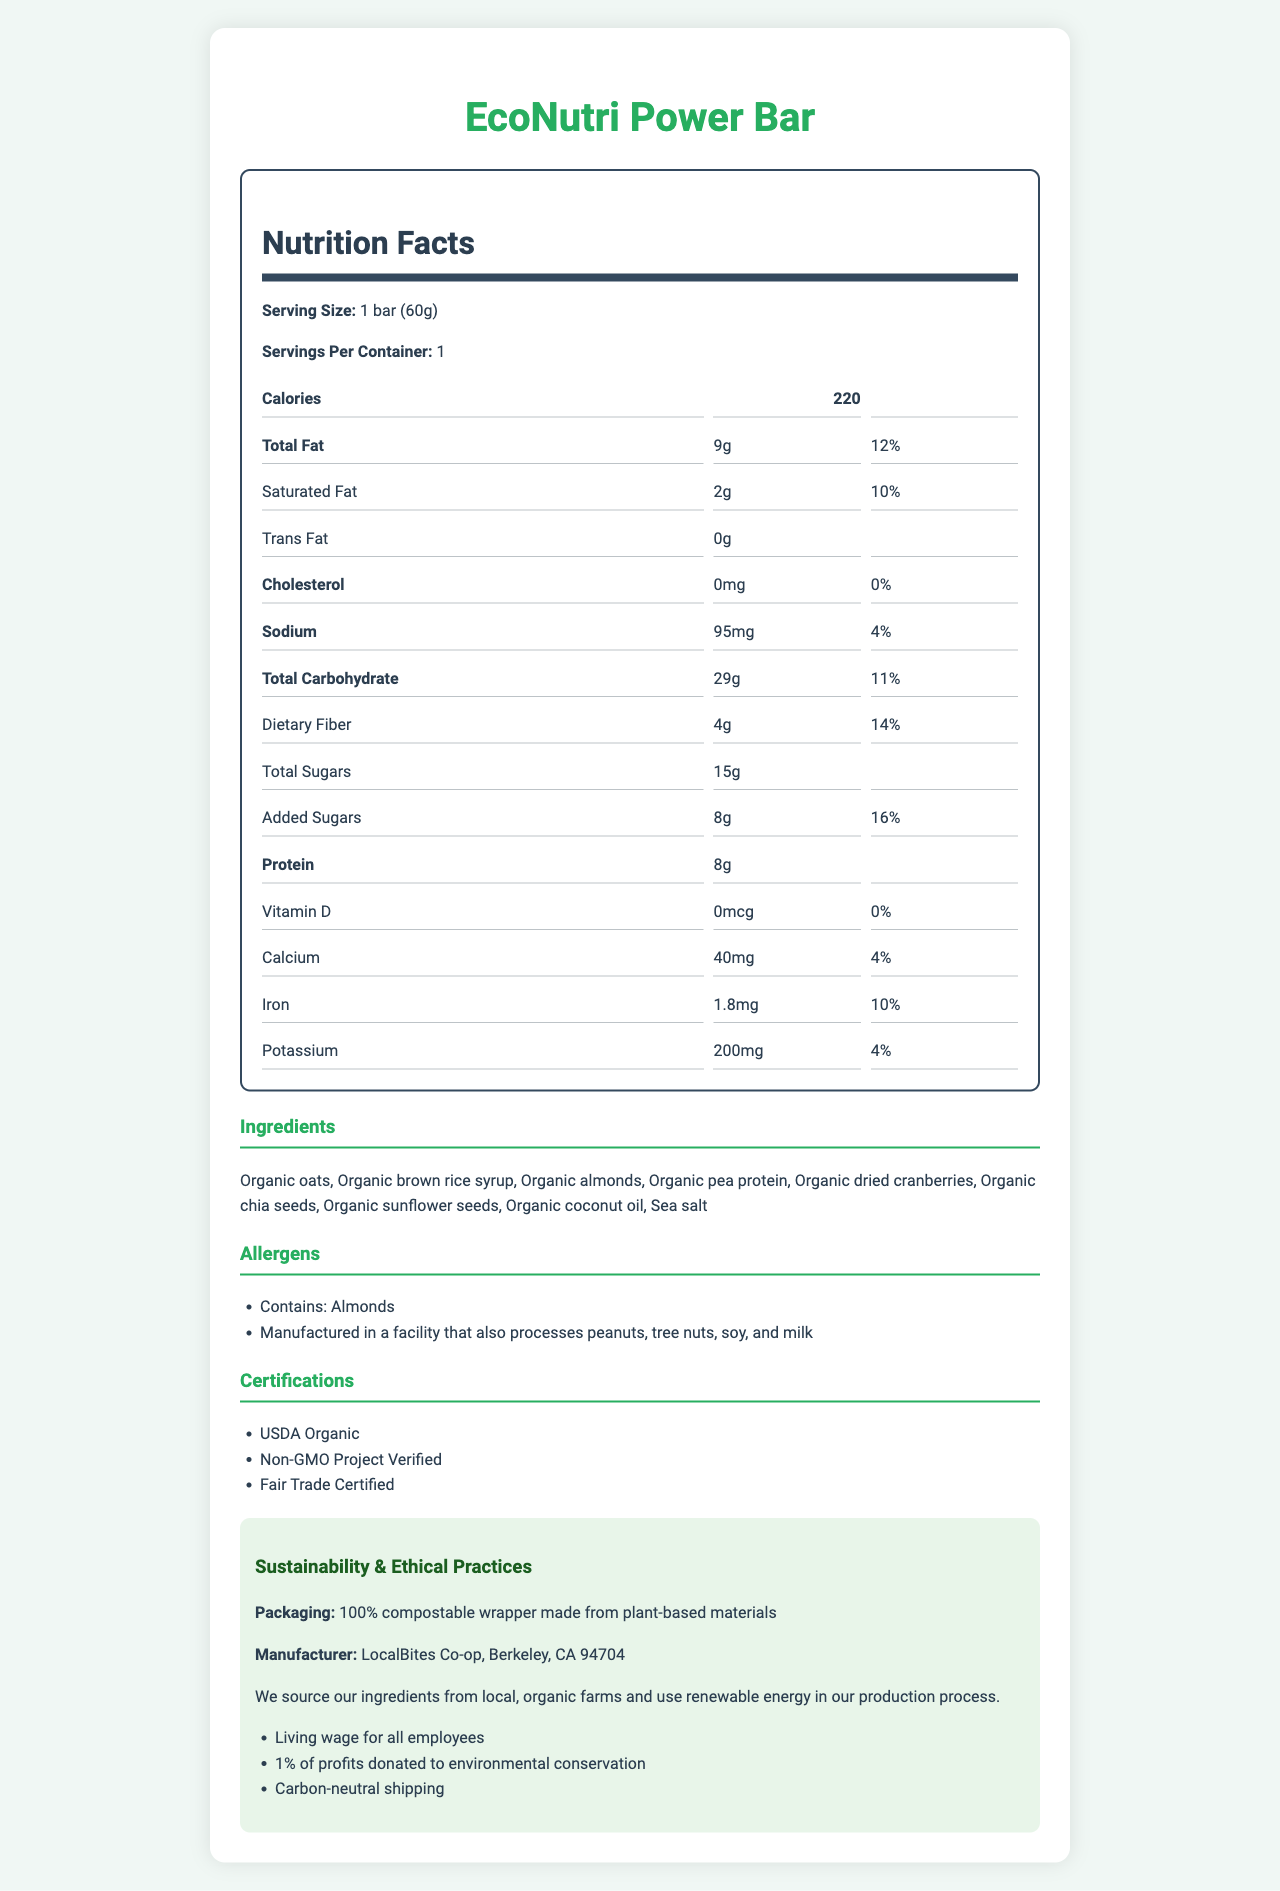what is the product name? The product name is listed at the top of the document.
Answer: EcoNutri Power Bar what is the serving size for the EcoNutri Power Bar? The serving size is stated under the Nutrition Facts section.
Answer: 1 bar (60g) how many calories are there in one serving? The number of calories per serving is provided in the Nutrition Facts section.
Answer: 220 what is the total amount of sugars in one EcoNutri Power Bar? The total amount of sugars is listed under the Nutrition Facts section.
Answer: 15g what are the main ingredients of the EcoNutri Power Bar? The ingredients are listed under the Ingredients section.
Answer: Organic oats, Organic brown rice syrup, Organic almonds, Organic pea protein, Organic dried cranberries, Organic chia seeds, Organic sunflower seeds, Organic coconut oil, Sea salt which certification does the EcoNutri Power Bar have? A. USDA Organic B. Non-GMO Project Verified C. Fair Trade Certified D. All of the above The document lists all these certifications under the Certifications section.
Answer: D which ingredient is a potential allergen? A. Chia seeds B. Almonds C. Oats D. Cranberries Almonds are explicitly listed as a potential allergen in the Allergens section.
Answer: B is the EcoNutri Power Bar free from trans fats? The Nutrition Facts section mentions that the amount of trans fat is 0g.
Answer: Yes does the EcoNutri Power Bar contain any added sugars? The Nutrition Facts section shows 8g of added sugars.
Answer: Yes describe the sustainability practices of LocalBites Co-op. The sustainability practices are detailed under the Sustainability & Ethical Practices section, providing a comprehensive view of their commitment to the environment.
Answer: LocalBites Co-op sources ingredients from local, organic farms, uses renewable energy in production, offers living wages to employees, donates 1% of profits to environmental conservation, and ensures carbon-neutral shipping. how much protein is in one serving of the EcoNutri Power Bar? The amount of protein per serving is listed in the Nutrition Facts section.
Answer: 8g what is the daily value percentage of dietary fiber in one serving? The daily value percentage of dietary fiber is given in the Nutrition Facts section.
Answer: 14% who manufactures the EcoNutri Power Bar? A. Berkeley Foods B. LocalBites Co-op C. Organic Snacks Co. D. Fair Trade Foods The manufacturer, LocalBites Co-op, is listed under the Sustainability & Ethical Practices section.
Answer: B how many servings are there in one container of EcoNutri Power Bar? The number of servings per container is mentioned under the Nutrition Facts section.
Answer: 1 what is the total carbohydrate content of one EcoNutri Power Bar? The total carbohydrate content is listed under the Nutrition Facts section.
Answer: 29g what type of packaging does the EcoNutri Power Bar use? This information is provided under the Sustainability & Ethical Practices section.
Answer: 100% compostable wrapper made from plant-based materials what percentage of daily value is the calcium content? The daily value percentage for calcium is listed in the Nutrition Facts section.
Answer: 4% where is LocalBites Co-op located? The location of the manufacturer is given under the Sustainability & Ethical Practices section.
Answer: Berkeley, CA 94704 does the document indicate the vitamin D content of the EcoNutri Power Bar? The Nutrition Facts section shows the amount of vitamin D as 0mcg with a daily value percentage of 0%.
Answer: Yes how many grams of saturated fat does one bar contain? The amount of saturated fat is listed in the Nutrition Facts section.
Answer: 2g which ingredient is not mentioned in the document? Honey is not listed among the ingredients of the EcoNutri Power Bar.
Answer: Honey 